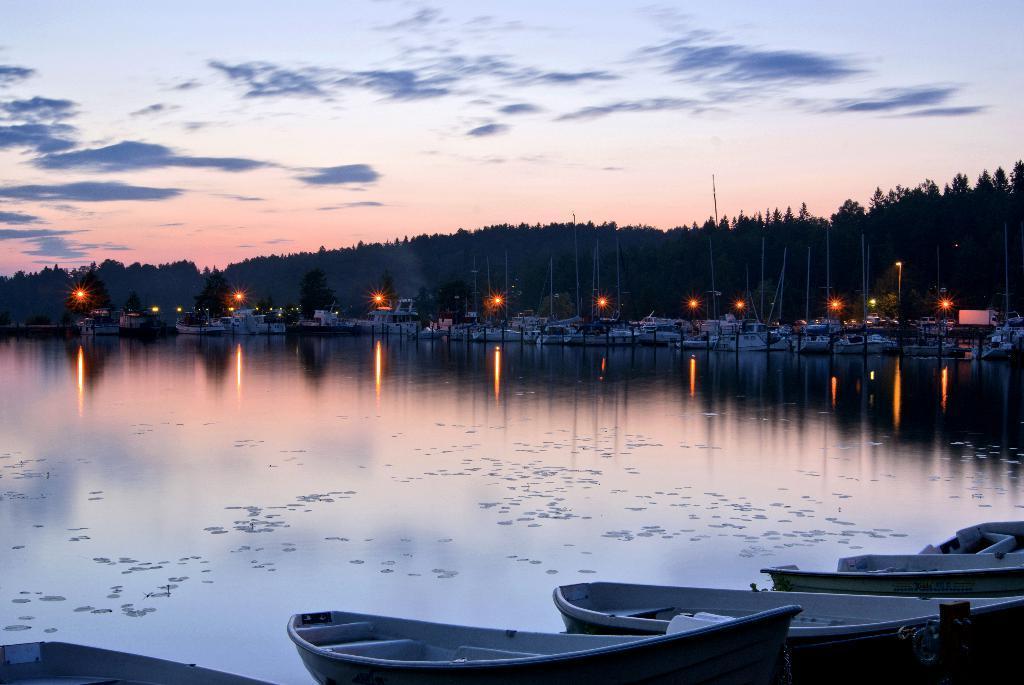Could you give a brief overview of what you see in this image? In this image at the bottom we can see boats and water. In the background there are ships on the water, lights, poles, trees, objects and clouds in the sky. 